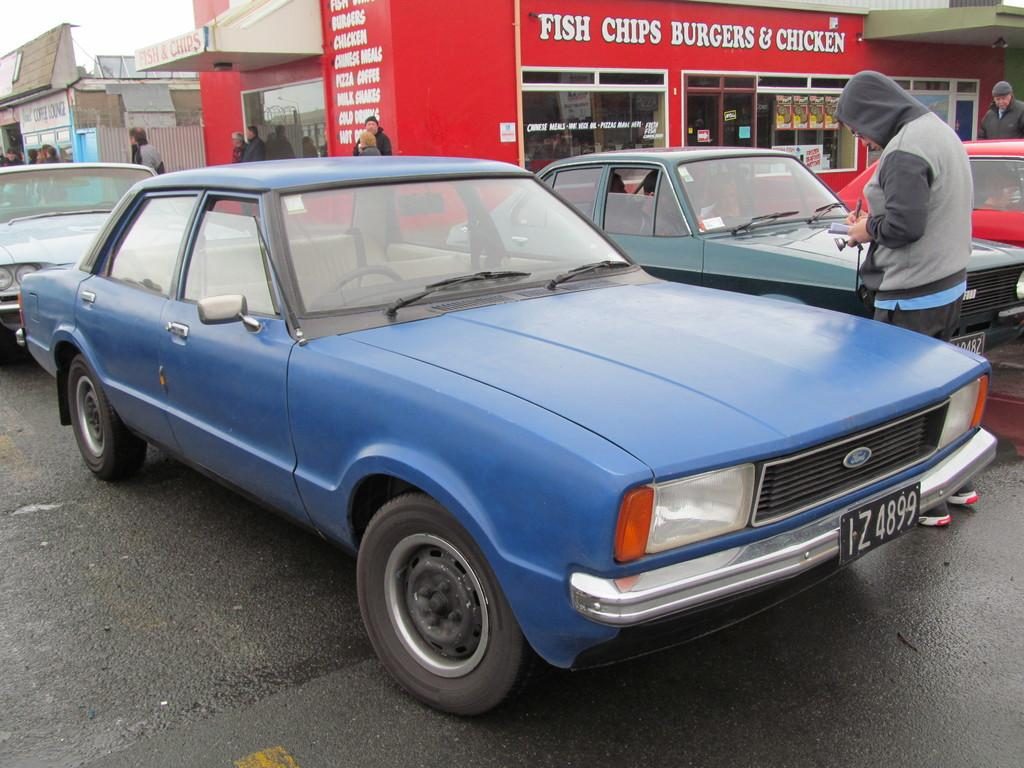Provide a one-sentence caption for the provided image. Several cars are parked in front of a restaurant that serves fish, chips, burgers and chicken. 